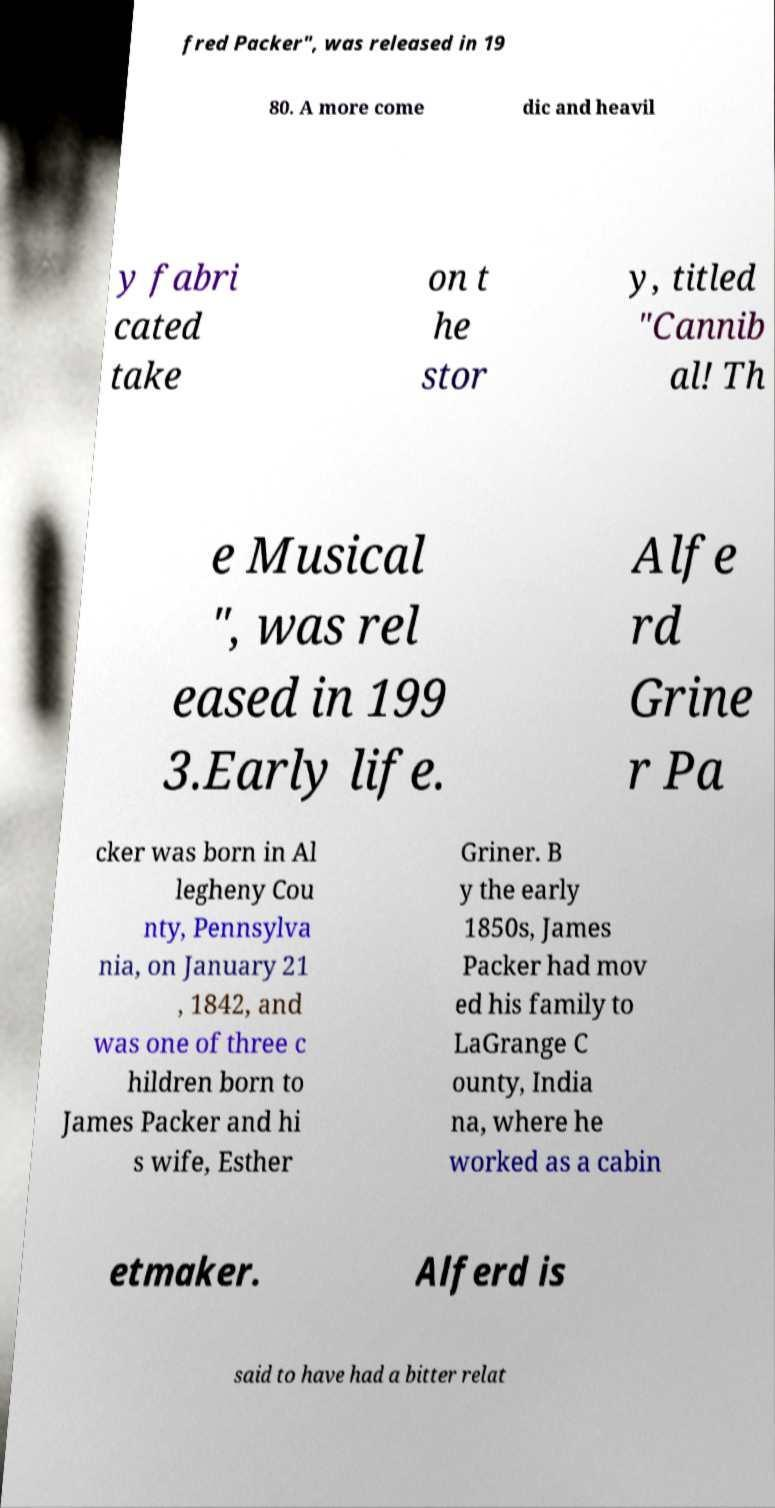I need the written content from this picture converted into text. Can you do that? fred Packer", was released in 19 80. A more come dic and heavil y fabri cated take on t he stor y, titled "Cannib al! Th e Musical ", was rel eased in 199 3.Early life. Alfe rd Grine r Pa cker was born in Al legheny Cou nty, Pennsylva nia, on January 21 , 1842, and was one of three c hildren born to James Packer and hi s wife, Esther Griner. B y the early 1850s, James Packer had mov ed his family to LaGrange C ounty, India na, where he worked as a cabin etmaker. Alferd is said to have had a bitter relat 